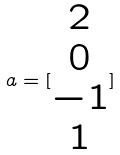Convert formula to latex. <formula><loc_0><loc_0><loc_500><loc_500>a = [ \begin{matrix} 2 \\ 0 \\ - 1 \\ 1 \end{matrix} ]</formula> 